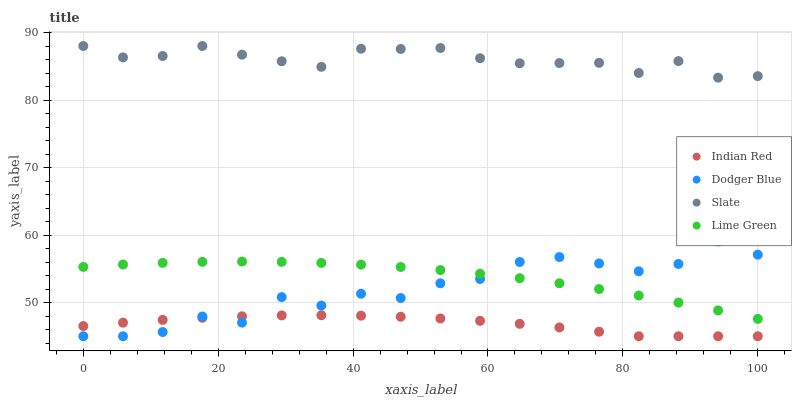Does Indian Red have the minimum area under the curve?
Answer yes or no. Yes. Does Slate have the maximum area under the curve?
Answer yes or no. Yes. Does Dodger Blue have the minimum area under the curve?
Answer yes or no. No. Does Dodger Blue have the maximum area under the curve?
Answer yes or no. No. Is Lime Green the smoothest?
Answer yes or no. Yes. Is Dodger Blue the roughest?
Answer yes or no. Yes. Is Slate the smoothest?
Answer yes or no. No. Is Slate the roughest?
Answer yes or no. No. Does Dodger Blue have the lowest value?
Answer yes or no. Yes. Does Slate have the lowest value?
Answer yes or no. No. Does Slate have the highest value?
Answer yes or no. Yes. Does Dodger Blue have the highest value?
Answer yes or no. No. Is Indian Red less than Lime Green?
Answer yes or no. Yes. Is Lime Green greater than Indian Red?
Answer yes or no. Yes. Does Indian Red intersect Dodger Blue?
Answer yes or no. Yes. Is Indian Red less than Dodger Blue?
Answer yes or no. No. Is Indian Red greater than Dodger Blue?
Answer yes or no. No. Does Indian Red intersect Lime Green?
Answer yes or no. No. 